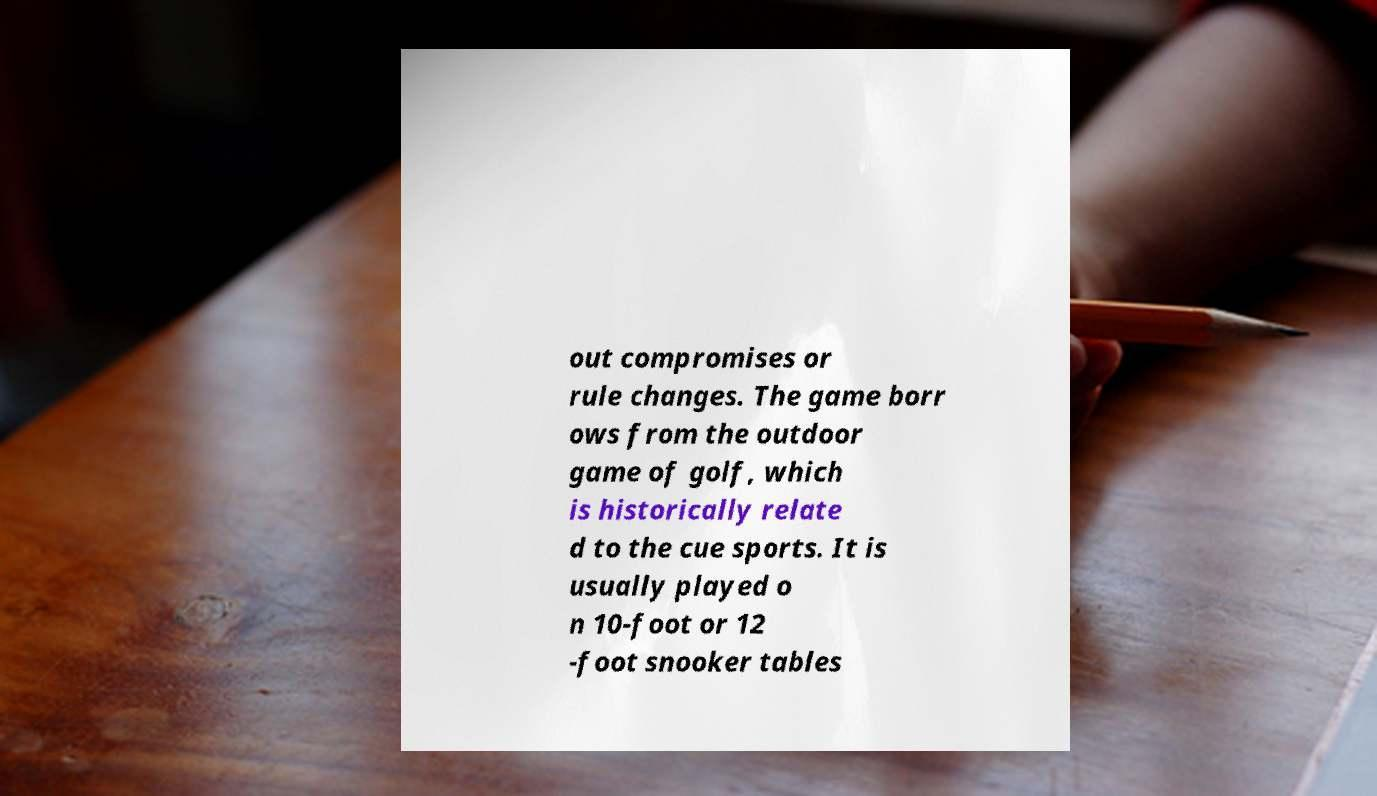Could you assist in decoding the text presented in this image and type it out clearly? out compromises or rule changes. The game borr ows from the outdoor game of golf, which is historically relate d to the cue sports. It is usually played o n 10-foot or 12 -foot snooker tables 